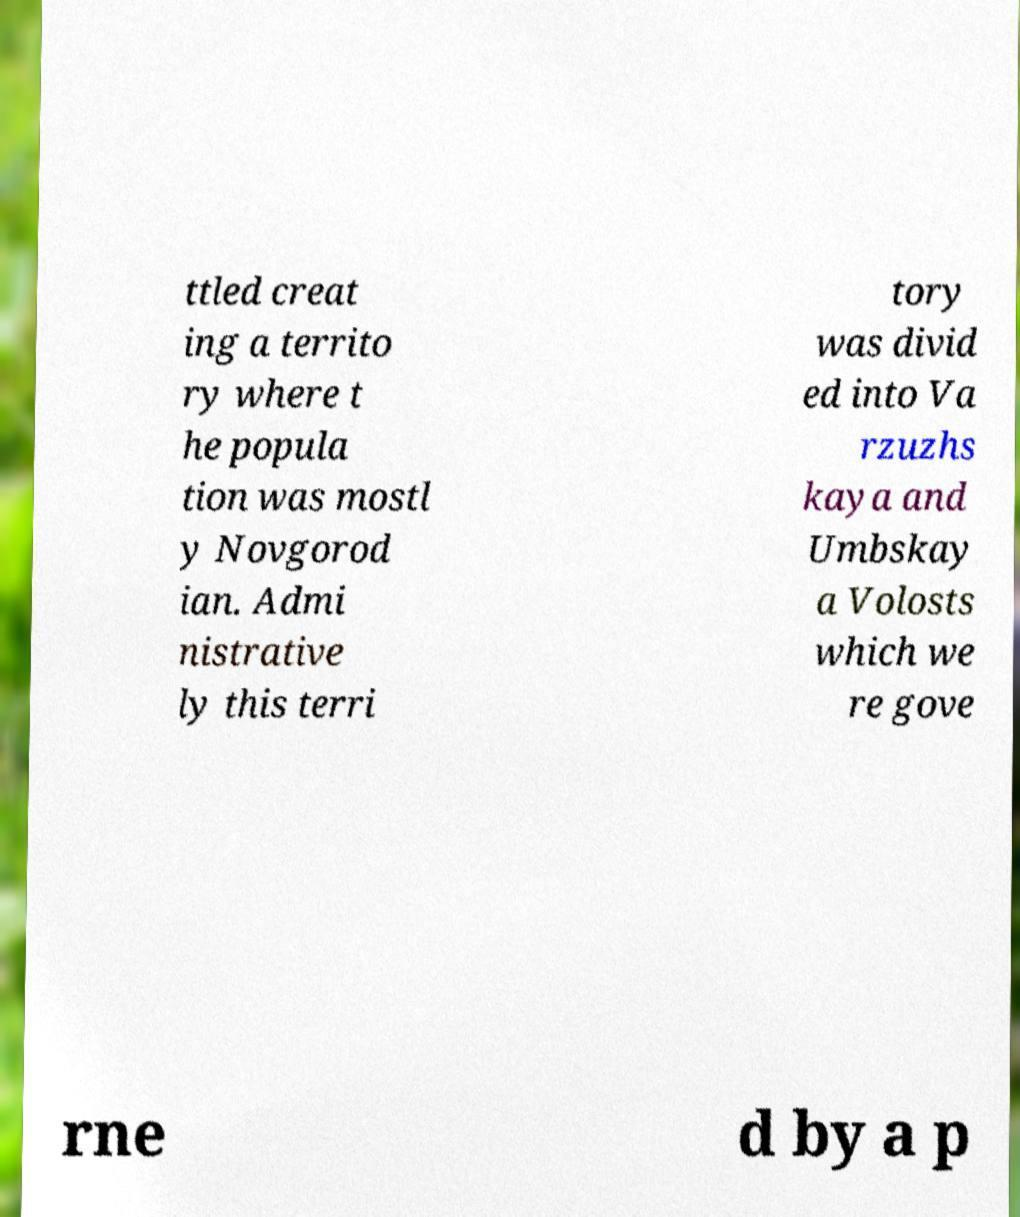Please read and relay the text visible in this image. What does it say? ttled creat ing a territo ry where t he popula tion was mostl y Novgorod ian. Admi nistrative ly this terri tory was divid ed into Va rzuzhs kaya and Umbskay a Volosts which we re gove rne d by a p 